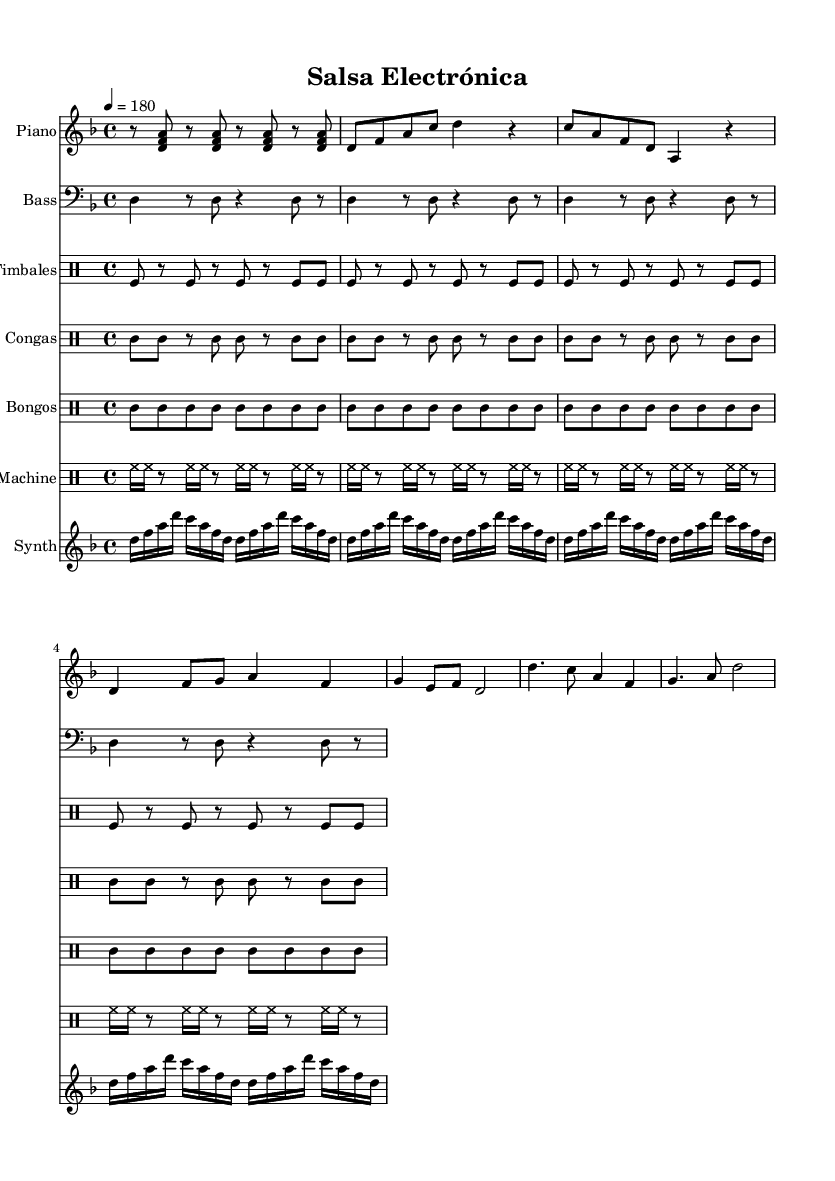What is the key signature of this music? The key signature indicated at the beginning of the sheet music is D minor, which has one flat (B flat).
Answer: D minor What is the time signature of this music? The time signature is displayed at the beginning of the score. It indicates that each measure contains four beats, with the quarter note receiving one beat.
Answer: 4/4 What is the tempo marking of this music? The tempo marking specifies the speed, which is indicated at the beginning as a metronome marking of 180 beats per minute.
Answer: 180 Which instruments are included in this piece? The instruments listed in the score are Piano, Bass, Timbales, Congas, Bongos, Drum Machine, and Synthesizer.
Answer: Piano, Bass, Timbales, Congas, Bongos, Drum Machine, Synthesizer What type of electronic sound is featured prominently in this score? The score includes a synthesizer part which plays repetitive melodic motifs that are characteristic of electronic music.
Answer: Synthesizer How is the rhythm of the congas and timbales similar? Both parts follow a consistent eighth-note rhythm, creating a driving pattern essential for salsa music.
Answer: Consistent eighth-note rhythm What unique element does the drum machine add to the traditional salsa sound? The drum machine adds a higher-speed hi-hat pattern that differs from the acoustic percussion elements, enhancing the electronic feel of the arrangement.
Answer: Hi-hat pattern 